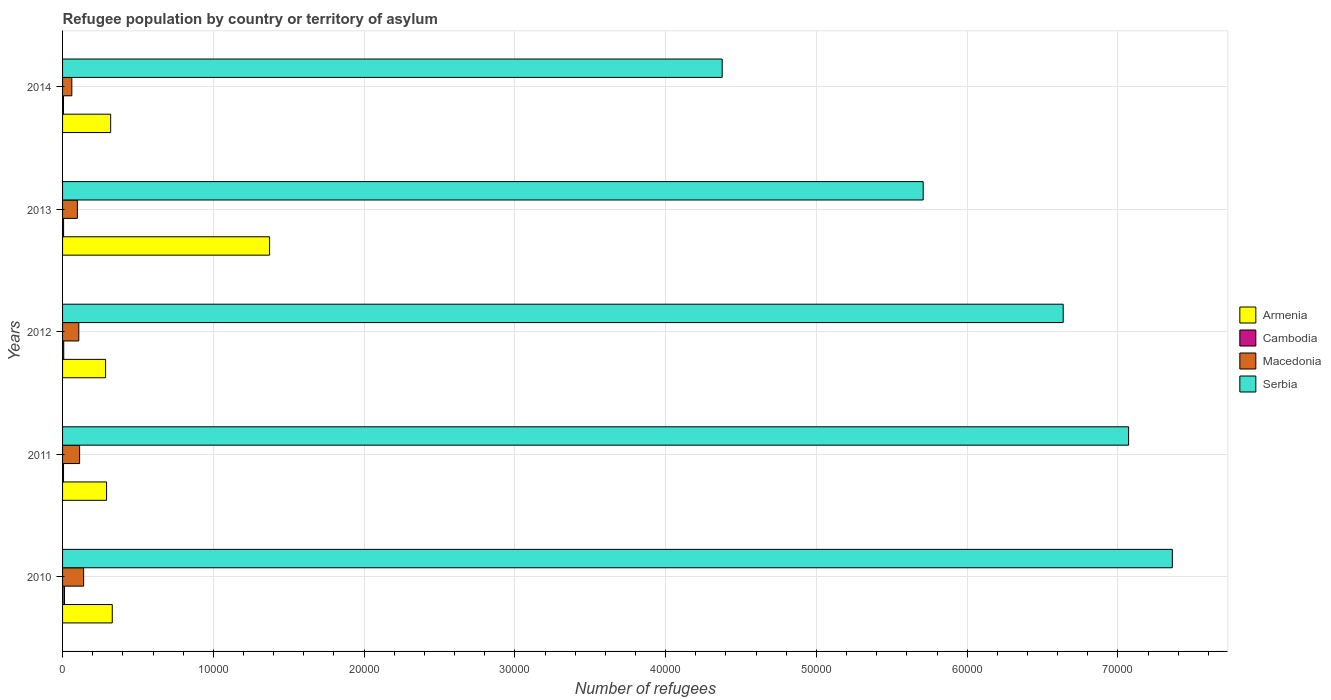How many bars are there on the 1st tick from the top?
Make the answer very short. 4. How many bars are there on the 5th tick from the bottom?
Provide a short and direct response. 4. In how many cases, is the number of bars for a given year not equal to the number of legend labels?
Your answer should be very brief. 0. Across all years, what is the maximum number of refugees in Armenia?
Offer a terse response. 1.37e+04. Across all years, what is the minimum number of refugees in Macedonia?
Offer a terse response. 614. In which year was the number of refugees in Cambodia maximum?
Provide a short and direct response. 2010. What is the total number of refugees in Macedonia in the graph?
Your answer should be very brief. 5201. What is the difference between the number of refugees in Armenia in 2012 and that in 2014?
Provide a short and direct response. -336. What is the difference between the number of refugees in Cambodia in 2010 and the number of refugees in Serbia in 2014?
Ensure brevity in your answer.  -4.36e+04. What is the average number of refugees in Cambodia per year?
Your answer should be compact. 80.2. In the year 2011, what is the difference between the number of refugees in Serbia and number of refugees in Armenia?
Keep it short and to the point. 6.78e+04. In how many years, is the number of refugees in Macedonia greater than 30000 ?
Make the answer very short. 0. What is the ratio of the number of refugees in Cambodia in 2011 to that in 2013?
Give a very brief answer. 0.94. Is the number of refugees in Armenia in 2010 less than that in 2011?
Provide a short and direct response. No. Is the difference between the number of refugees in Serbia in 2011 and 2012 greater than the difference between the number of refugees in Armenia in 2011 and 2012?
Your answer should be compact. Yes. What is the difference between the highest and the second highest number of refugees in Serbia?
Provide a succinct answer. 2901. In how many years, is the number of refugees in Serbia greater than the average number of refugees in Serbia taken over all years?
Your answer should be very brief. 3. What does the 1st bar from the top in 2010 represents?
Provide a succinct answer. Serbia. What does the 2nd bar from the bottom in 2010 represents?
Offer a terse response. Cambodia. Is it the case that in every year, the sum of the number of refugees in Macedonia and number of refugees in Armenia is greater than the number of refugees in Cambodia?
Offer a very short reply. Yes. Are all the bars in the graph horizontal?
Make the answer very short. Yes. How many years are there in the graph?
Offer a terse response. 5. What is the difference between two consecutive major ticks on the X-axis?
Offer a terse response. 10000. Are the values on the major ticks of X-axis written in scientific E-notation?
Your answer should be very brief. No. Where does the legend appear in the graph?
Your answer should be compact. Center right. What is the title of the graph?
Ensure brevity in your answer.  Refugee population by country or territory of asylum. Does "Faeroe Islands" appear as one of the legend labels in the graph?
Provide a short and direct response. No. What is the label or title of the X-axis?
Ensure brevity in your answer.  Number of refugees. What is the label or title of the Y-axis?
Make the answer very short. Years. What is the Number of refugees in Armenia in 2010?
Keep it short and to the point. 3296. What is the Number of refugees of Cambodia in 2010?
Your answer should be compact. 129. What is the Number of refugees in Macedonia in 2010?
Give a very brief answer. 1398. What is the Number of refugees of Serbia in 2010?
Make the answer very short. 7.36e+04. What is the Number of refugees of Armenia in 2011?
Keep it short and to the point. 2918. What is the Number of refugees in Cambodia in 2011?
Your answer should be compact. 64. What is the Number of refugees of Macedonia in 2011?
Offer a terse response. 1130. What is the Number of refugees of Serbia in 2011?
Provide a short and direct response. 7.07e+04. What is the Number of refugees of Armenia in 2012?
Offer a terse response. 2854. What is the Number of refugees in Macedonia in 2012?
Provide a succinct answer. 1077. What is the Number of refugees in Serbia in 2012?
Keep it short and to the point. 6.64e+04. What is the Number of refugees of Armenia in 2013?
Make the answer very short. 1.37e+04. What is the Number of refugees in Cambodia in 2013?
Offer a very short reply. 68. What is the Number of refugees of Macedonia in 2013?
Your answer should be very brief. 982. What is the Number of refugees of Serbia in 2013?
Your answer should be compact. 5.71e+04. What is the Number of refugees in Armenia in 2014?
Your answer should be compact. 3190. What is the Number of refugees of Cambodia in 2014?
Make the answer very short. 63. What is the Number of refugees of Macedonia in 2014?
Ensure brevity in your answer.  614. What is the Number of refugees in Serbia in 2014?
Provide a short and direct response. 4.38e+04. Across all years, what is the maximum Number of refugees in Armenia?
Your answer should be compact. 1.37e+04. Across all years, what is the maximum Number of refugees of Cambodia?
Make the answer very short. 129. Across all years, what is the maximum Number of refugees in Macedonia?
Provide a succinct answer. 1398. Across all years, what is the maximum Number of refugees in Serbia?
Offer a very short reply. 7.36e+04. Across all years, what is the minimum Number of refugees of Armenia?
Provide a short and direct response. 2854. Across all years, what is the minimum Number of refugees of Macedonia?
Your response must be concise. 614. Across all years, what is the minimum Number of refugees of Serbia?
Your response must be concise. 4.38e+04. What is the total Number of refugees of Armenia in the graph?
Provide a succinct answer. 2.60e+04. What is the total Number of refugees of Cambodia in the graph?
Your response must be concise. 401. What is the total Number of refugees in Macedonia in the graph?
Keep it short and to the point. 5201. What is the total Number of refugees of Serbia in the graph?
Offer a terse response. 3.12e+05. What is the difference between the Number of refugees in Armenia in 2010 and that in 2011?
Make the answer very short. 378. What is the difference between the Number of refugees in Cambodia in 2010 and that in 2011?
Offer a terse response. 65. What is the difference between the Number of refugees of Macedonia in 2010 and that in 2011?
Offer a terse response. 268. What is the difference between the Number of refugees in Serbia in 2010 and that in 2011?
Offer a terse response. 2901. What is the difference between the Number of refugees of Armenia in 2010 and that in 2012?
Offer a very short reply. 442. What is the difference between the Number of refugees of Macedonia in 2010 and that in 2012?
Your answer should be very brief. 321. What is the difference between the Number of refugees of Serbia in 2010 and that in 2012?
Make the answer very short. 7238. What is the difference between the Number of refugees in Armenia in 2010 and that in 2013?
Keep it short and to the point. -1.04e+04. What is the difference between the Number of refugees of Cambodia in 2010 and that in 2013?
Provide a short and direct response. 61. What is the difference between the Number of refugees in Macedonia in 2010 and that in 2013?
Ensure brevity in your answer.  416. What is the difference between the Number of refugees in Serbia in 2010 and that in 2013?
Offer a terse response. 1.65e+04. What is the difference between the Number of refugees of Armenia in 2010 and that in 2014?
Your response must be concise. 106. What is the difference between the Number of refugees of Cambodia in 2010 and that in 2014?
Give a very brief answer. 66. What is the difference between the Number of refugees in Macedonia in 2010 and that in 2014?
Your answer should be very brief. 784. What is the difference between the Number of refugees in Serbia in 2010 and that in 2014?
Keep it short and to the point. 2.99e+04. What is the difference between the Number of refugees of Armenia in 2011 and that in 2012?
Ensure brevity in your answer.  64. What is the difference between the Number of refugees in Cambodia in 2011 and that in 2012?
Make the answer very short. -13. What is the difference between the Number of refugees in Macedonia in 2011 and that in 2012?
Make the answer very short. 53. What is the difference between the Number of refugees in Serbia in 2011 and that in 2012?
Your answer should be very brief. 4337. What is the difference between the Number of refugees of Armenia in 2011 and that in 2013?
Offer a terse response. -1.08e+04. What is the difference between the Number of refugees of Macedonia in 2011 and that in 2013?
Keep it short and to the point. 148. What is the difference between the Number of refugees in Serbia in 2011 and that in 2013?
Your answer should be compact. 1.36e+04. What is the difference between the Number of refugees of Armenia in 2011 and that in 2014?
Your answer should be very brief. -272. What is the difference between the Number of refugees of Macedonia in 2011 and that in 2014?
Make the answer very short. 516. What is the difference between the Number of refugees in Serbia in 2011 and that in 2014?
Provide a short and direct response. 2.70e+04. What is the difference between the Number of refugees in Armenia in 2012 and that in 2013?
Offer a terse response. -1.09e+04. What is the difference between the Number of refugees in Macedonia in 2012 and that in 2013?
Your answer should be very brief. 95. What is the difference between the Number of refugees of Serbia in 2012 and that in 2013?
Ensure brevity in your answer.  9287. What is the difference between the Number of refugees in Armenia in 2012 and that in 2014?
Keep it short and to the point. -336. What is the difference between the Number of refugees in Macedonia in 2012 and that in 2014?
Offer a terse response. 463. What is the difference between the Number of refugees of Serbia in 2012 and that in 2014?
Make the answer very short. 2.26e+04. What is the difference between the Number of refugees of Armenia in 2013 and that in 2014?
Provide a succinct answer. 1.05e+04. What is the difference between the Number of refugees of Macedonia in 2013 and that in 2014?
Your response must be concise. 368. What is the difference between the Number of refugees of Serbia in 2013 and that in 2014?
Your answer should be very brief. 1.33e+04. What is the difference between the Number of refugees in Armenia in 2010 and the Number of refugees in Cambodia in 2011?
Make the answer very short. 3232. What is the difference between the Number of refugees in Armenia in 2010 and the Number of refugees in Macedonia in 2011?
Ensure brevity in your answer.  2166. What is the difference between the Number of refugees of Armenia in 2010 and the Number of refugees of Serbia in 2011?
Your answer should be compact. -6.74e+04. What is the difference between the Number of refugees of Cambodia in 2010 and the Number of refugees of Macedonia in 2011?
Ensure brevity in your answer.  -1001. What is the difference between the Number of refugees in Cambodia in 2010 and the Number of refugees in Serbia in 2011?
Keep it short and to the point. -7.06e+04. What is the difference between the Number of refugees of Macedonia in 2010 and the Number of refugees of Serbia in 2011?
Ensure brevity in your answer.  -6.93e+04. What is the difference between the Number of refugees in Armenia in 2010 and the Number of refugees in Cambodia in 2012?
Ensure brevity in your answer.  3219. What is the difference between the Number of refugees in Armenia in 2010 and the Number of refugees in Macedonia in 2012?
Keep it short and to the point. 2219. What is the difference between the Number of refugees in Armenia in 2010 and the Number of refugees in Serbia in 2012?
Offer a terse response. -6.31e+04. What is the difference between the Number of refugees in Cambodia in 2010 and the Number of refugees in Macedonia in 2012?
Your response must be concise. -948. What is the difference between the Number of refugees of Cambodia in 2010 and the Number of refugees of Serbia in 2012?
Keep it short and to the point. -6.62e+04. What is the difference between the Number of refugees in Macedonia in 2010 and the Number of refugees in Serbia in 2012?
Provide a short and direct response. -6.50e+04. What is the difference between the Number of refugees in Armenia in 2010 and the Number of refugees in Cambodia in 2013?
Provide a succinct answer. 3228. What is the difference between the Number of refugees of Armenia in 2010 and the Number of refugees of Macedonia in 2013?
Ensure brevity in your answer.  2314. What is the difference between the Number of refugees of Armenia in 2010 and the Number of refugees of Serbia in 2013?
Offer a very short reply. -5.38e+04. What is the difference between the Number of refugees of Cambodia in 2010 and the Number of refugees of Macedonia in 2013?
Your answer should be very brief. -853. What is the difference between the Number of refugees of Cambodia in 2010 and the Number of refugees of Serbia in 2013?
Provide a short and direct response. -5.70e+04. What is the difference between the Number of refugees of Macedonia in 2010 and the Number of refugees of Serbia in 2013?
Provide a succinct answer. -5.57e+04. What is the difference between the Number of refugees of Armenia in 2010 and the Number of refugees of Cambodia in 2014?
Provide a succinct answer. 3233. What is the difference between the Number of refugees of Armenia in 2010 and the Number of refugees of Macedonia in 2014?
Your answer should be very brief. 2682. What is the difference between the Number of refugees in Armenia in 2010 and the Number of refugees in Serbia in 2014?
Provide a succinct answer. -4.05e+04. What is the difference between the Number of refugees of Cambodia in 2010 and the Number of refugees of Macedonia in 2014?
Your answer should be compact. -485. What is the difference between the Number of refugees of Cambodia in 2010 and the Number of refugees of Serbia in 2014?
Offer a very short reply. -4.36e+04. What is the difference between the Number of refugees in Macedonia in 2010 and the Number of refugees in Serbia in 2014?
Provide a succinct answer. -4.24e+04. What is the difference between the Number of refugees in Armenia in 2011 and the Number of refugees in Cambodia in 2012?
Your answer should be very brief. 2841. What is the difference between the Number of refugees of Armenia in 2011 and the Number of refugees of Macedonia in 2012?
Make the answer very short. 1841. What is the difference between the Number of refugees of Armenia in 2011 and the Number of refugees of Serbia in 2012?
Offer a terse response. -6.35e+04. What is the difference between the Number of refugees of Cambodia in 2011 and the Number of refugees of Macedonia in 2012?
Give a very brief answer. -1013. What is the difference between the Number of refugees of Cambodia in 2011 and the Number of refugees of Serbia in 2012?
Provide a succinct answer. -6.63e+04. What is the difference between the Number of refugees of Macedonia in 2011 and the Number of refugees of Serbia in 2012?
Offer a very short reply. -6.52e+04. What is the difference between the Number of refugees of Armenia in 2011 and the Number of refugees of Cambodia in 2013?
Offer a terse response. 2850. What is the difference between the Number of refugees of Armenia in 2011 and the Number of refugees of Macedonia in 2013?
Keep it short and to the point. 1936. What is the difference between the Number of refugees of Armenia in 2011 and the Number of refugees of Serbia in 2013?
Your response must be concise. -5.42e+04. What is the difference between the Number of refugees of Cambodia in 2011 and the Number of refugees of Macedonia in 2013?
Your response must be concise. -918. What is the difference between the Number of refugees in Cambodia in 2011 and the Number of refugees in Serbia in 2013?
Make the answer very short. -5.70e+04. What is the difference between the Number of refugees of Macedonia in 2011 and the Number of refugees of Serbia in 2013?
Offer a very short reply. -5.60e+04. What is the difference between the Number of refugees in Armenia in 2011 and the Number of refugees in Cambodia in 2014?
Your answer should be very brief. 2855. What is the difference between the Number of refugees in Armenia in 2011 and the Number of refugees in Macedonia in 2014?
Offer a terse response. 2304. What is the difference between the Number of refugees of Armenia in 2011 and the Number of refugees of Serbia in 2014?
Offer a very short reply. -4.08e+04. What is the difference between the Number of refugees of Cambodia in 2011 and the Number of refugees of Macedonia in 2014?
Provide a succinct answer. -550. What is the difference between the Number of refugees of Cambodia in 2011 and the Number of refugees of Serbia in 2014?
Make the answer very short. -4.37e+04. What is the difference between the Number of refugees in Macedonia in 2011 and the Number of refugees in Serbia in 2014?
Give a very brief answer. -4.26e+04. What is the difference between the Number of refugees in Armenia in 2012 and the Number of refugees in Cambodia in 2013?
Your answer should be compact. 2786. What is the difference between the Number of refugees of Armenia in 2012 and the Number of refugees of Macedonia in 2013?
Ensure brevity in your answer.  1872. What is the difference between the Number of refugees of Armenia in 2012 and the Number of refugees of Serbia in 2013?
Provide a succinct answer. -5.42e+04. What is the difference between the Number of refugees in Cambodia in 2012 and the Number of refugees in Macedonia in 2013?
Your answer should be compact. -905. What is the difference between the Number of refugees in Cambodia in 2012 and the Number of refugees in Serbia in 2013?
Provide a succinct answer. -5.70e+04. What is the difference between the Number of refugees in Macedonia in 2012 and the Number of refugees in Serbia in 2013?
Your answer should be compact. -5.60e+04. What is the difference between the Number of refugees of Armenia in 2012 and the Number of refugees of Cambodia in 2014?
Provide a succinct answer. 2791. What is the difference between the Number of refugees of Armenia in 2012 and the Number of refugees of Macedonia in 2014?
Your response must be concise. 2240. What is the difference between the Number of refugees in Armenia in 2012 and the Number of refugees in Serbia in 2014?
Your answer should be compact. -4.09e+04. What is the difference between the Number of refugees in Cambodia in 2012 and the Number of refugees in Macedonia in 2014?
Your answer should be very brief. -537. What is the difference between the Number of refugees of Cambodia in 2012 and the Number of refugees of Serbia in 2014?
Ensure brevity in your answer.  -4.37e+04. What is the difference between the Number of refugees of Macedonia in 2012 and the Number of refugees of Serbia in 2014?
Offer a very short reply. -4.27e+04. What is the difference between the Number of refugees of Armenia in 2013 and the Number of refugees of Cambodia in 2014?
Your answer should be very brief. 1.37e+04. What is the difference between the Number of refugees in Armenia in 2013 and the Number of refugees in Macedonia in 2014?
Keep it short and to the point. 1.31e+04. What is the difference between the Number of refugees of Armenia in 2013 and the Number of refugees of Serbia in 2014?
Give a very brief answer. -3.00e+04. What is the difference between the Number of refugees in Cambodia in 2013 and the Number of refugees in Macedonia in 2014?
Provide a short and direct response. -546. What is the difference between the Number of refugees in Cambodia in 2013 and the Number of refugees in Serbia in 2014?
Give a very brief answer. -4.37e+04. What is the difference between the Number of refugees in Macedonia in 2013 and the Number of refugees in Serbia in 2014?
Your answer should be compact. -4.28e+04. What is the average Number of refugees in Armenia per year?
Provide a short and direct response. 5198. What is the average Number of refugees in Cambodia per year?
Your response must be concise. 80.2. What is the average Number of refugees of Macedonia per year?
Your answer should be compact. 1040.2. What is the average Number of refugees in Serbia per year?
Keep it short and to the point. 6.23e+04. In the year 2010, what is the difference between the Number of refugees in Armenia and Number of refugees in Cambodia?
Ensure brevity in your answer.  3167. In the year 2010, what is the difference between the Number of refugees of Armenia and Number of refugees of Macedonia?
Your answer should be very brief. 1898. In the year 2010, what is the difference between the Number of refugees in Armenia and Number of refugees in Serbia?
Offer a very short reply. -7.03e+04. In the year 2010, what is the difference between the Number of refugees of Cambodia and Number of refugees of Macedonia?
Offer a terse response. -1269. In the year 2010, what is the difference between the Number of refugees in Cambodia and Number of refugees in Serbia?
Offer a terse response. -7.35e+04. In the year 2010, what is the difference between the Number of refugees of Macedonia and Number of refugees of Serbia?
Offer a very short reply. -7.22e+04. In the year 2011, what is the difference between the Number of refugees of Armenia and Number of refugees of Cambodia?
Your answer should be very brief. 2854. In the year 2011, what is the difference between the Number of refugees in Armenia and Number of refugees in Macedonia?
Give a very brief answer. 1788. In the year 2011, what is the difference between the Number of refugees in Armenia and Number of refugees in Serbia?
Your answer should be very brief. -6.78e+04. In the year 2011, what is the difference between the Number of refugees of Cambodia and Number of refugees of Macedonia?
Ensure brevity in your answer.  -1066. In the year 2011, what is the difference between the Number of refugees in Cambodia and Number of refugees in Serbia?
Offer a terse response. -7.06e+04. In the year 2011, what is the difference between the Number of refugees of Macedonia and Number of refugees of Serbia?
Your answer should be very brief. -6.96e+04. In the year 2012, what is the difference between the Number of refugees of Armenia and Number of refugees of Cambodia?
Keep it short and to the point. 2777. In the year 2012, what is the difference between the Number of refugees of Armenia and Number of refugees of Macedonia?
Your answer should be compact. 1777. In the year 2012, what is the difference between the Number of refugees of Armenia and Number of refugees of Serbia?
Give a very brief answer. -6.35e+04. In the year 2012, what is the difference between the Number of refugees of Cambodia and Number of refugees of Macedonia?
Keep it short and to the point. -1000. In the year 2012, what is the difference between the Number of refugees of Cambodia and Number of refugees of Serbia?
Your response must be concise. -6.63e+04. In the year 2012, what is the difference between the Number of refugees in Macedonia and Number of refugees in Serbia?
Provide a succinct answer. -6.53e+04. In the year 2013, what is the difference between the Number of refugees of Armenia and Number of refugees of Cambodia?
Keep it short and to the point. 1.37e+04. In the year 2013, what is the difference between the Number of refugees in Armenia and Number of refugees in Macedonia?
Offer a very short reply. 1.28e+04. In the year 2013, what is the difference between the Number of refugees of Armenia and Number of refugees of Serbia?
Offer a terse response. -4.34e+04. In the year 2013, what is the difference between the Number of refugees in Cambodia and Number of refugees in Macedonia?
Your answer should be compact. -914. In the year 2013, what is the difference between the Number of refugees in Cambodia and Number of refugees in Serbia?
Ensure brevity in your answer.  -5.70e+04. In the year 2013, what is the difference between the Number of refugees of Macedonia and Number of refugees of Serbia?
Ensure brevity in your answer.  -5.61e+04. In the year 2014, what is the difference between the Number of refugees of Armenia and Number of refugees of Cambodia?
Provide a succinct answer. 3127. In the year 2014, what is the difference between the Number of refugees in Armenia and Number of refugees in Macedonia?
Provide a succinct answer. 2576. In the year 2014, what is the difference between the Number of refugees of Armenia and Number of refugees of Serbia?
Provide a short and direct response. -4.06e+04. In the year 2014, what is the difference between the Number of refugees of Cambodia and Number of refugees of Macedonia?
Make the answer very short. -551. In the year 2014, what is the difference between the Number of refugees in Cambodia and Number of refugees in Serbia?
Your answer should be very brief. -4.37e+04. In the year 2014, what is the difference between the Number of refugees in Macedonia and Number of refugees in Serbia?
Your response must be concise. -4.31e+04. What is the ratio of the Number of refugees in Armenia in 2010 to that in 2011?
Keep it short and to the point. 1.13. What is the ratio of the Number of refugees in Cambodia in 2010 to that in 2011?
Your response must be concise. 2.02. What is the ratio of the Number of refugees of Macedonia in 2010 to that in 2011?
Keep it short and to the point. 1.24. What is the ratio of the Number of refugees of Serbia in 2010 to that in 2011?
Provide a short and direct response. 1.04. What is the ratio of the Number of refugees in Armenia in 2010 to that in 2012?
Ensure brevity in your answer.  1.15. What is the ratio of the Number of refugees of Cambodia in 2010 to that in 2012?
Provide a short and direct response. 1.68. What is the ratio of the Number of refugees of Macedonia in 2010 to that in 2012?
Your answer should be compact. 1.3. What is the ratio of the Number of refugees in Serbia in 2010 to that in 2012?
Offer a terse response. 1.11. What is the ratio of the Number of refugees of Armenia in 2010 to that in 2013?
Your response must be concise. 0.24. What is the ratio of the Number of refugees in Cambodia in 2010 to that in 2013?
Keep it short and to the point. 1.9. What is the ratio of the Number of refugees of Macedonia in 2010 to that in 2013?
Provide a short and direct response. 1.42. What is the ratio of the Number of refugees in Serbia in 2010 to that in 2013?
Offer a terse response. 1.29. What is the ratio of the Number of refugees of Armenia in 2010 to that in 2014?
Your response must be concise. 1.03. What is the ratio of the Number of refugees of Cambodia in 2010 to that in 2014?
Offer a very short reply. 2.05. What is the ratio of the Number of refugees of Macedonia in 2010 to that in 2014?
Make the answer very short. 2.28. What is the ratio of the Number of refugees in Serbia in 2010 to that in 2014?
Ensure brevity in your answer.  1.68. What is the ratio of the Number of refugees in Armenia in 2011 to that in 2012?
Offer a terse response. 1.02. What is the ratio of the Number of refugees of Cambodia in 2011 to that in 2012?
Offer a very short reply. 0.83. What is the ratio of the Number of refugees in Macedonia in 2011 to that in 2012?
Your response must be concise. 1.05. What is the ratio of the Number of refugees in Serbia in 2011 to that in 2012?
Your answer should be compact. 1.07. What is the ratio of the Number of refugees in Armenia in 2011 to that in 2013?
Give a very brief answer. 0.21. What is the ratio of the Number of refugees in Macedonia in 2011 to that in 2013?
Your response must be concise. 1.15. What is the ratio of the Number of refugees of Serbia in 2011 to that in 2013?
Ensure brevity in your answer.  1.24. What is the ratio of the Number of refugees of Armenia in 2011 to that in 2014?
Keep it short and to the point. 0.91. What is the ratio of the Number of refugees in Cambodia in 2011 to that in 2014?
Offer a terse response. 1.02. What is the ratio of the Number of refugees of Macedonia in 2011 to that in 2014?
Offer a very short reply. 1.84. What is the ratio of the Number of refugees in Serbia in 2011 to that in 2014?
Offer a very short reply. 1.62. What is the ratio of the Number of refugees of Armenia in 2012 to that in 2013?
Ensure brevity in your answer.  0.21. What is the ratio of the Number of refugees of Cambodia in 2012 to that in 2013?
Offer a very short reply. 1.13. What is the ratio of the Number of refugees in Macedonia in 2012 to that in 2013?
Offer a terse response. 1.1. What is the ratio of the Number of refugees in Serbia in 2012 to that in 2013?
Give a very brief answer. 1.16. What is the ratio of the Number of refugees in Armenia in 2012 to that in 2014?
Give a very brief answer. 0.89. What is the ratio of the Number of refugees of Cambodia in 2012 to that in 2014?
Your answer should be compact. 1.22. What is the ratio of the Number of refugees of Macedonia in 2012 to that in 2014?
Offer a very short reply. 1.75. What is the ratio of the Number of refugees in Serbia in 2012 to that in 2014?
Your answer should be compact. 1.52. What is the ratio of the Number of refugees in Armenia in 2013 to that in 2014?
Provide a short and direct response. 4.3. What is the ratio of the Number of refugees in Cambodia in 2013 to that in 2014?
Your answer should be very brief. 1.08. What is the ratio of the Number of refugees in Macedonia in 2013 to that in 2014?
Keep it short and to the point. 1.6. What is the ratio of the Number of refugees in Serbia in 2013 to that in 2014?
Keep it short and to the point. 1.3. What is the difference between the highest and the second highest Number of refugees of Armenia?
Offer a terse response. 1.04e+04. What is the difference between the highest and the second highest Number of refugees in Cambodia?
Keep it short and to the point. 52. What is the difference between the highest and the second highest Number of refugees of Macedonia?
Give a very brief answer. 268. What is the difference between the highest and the second highest Number of refugees in Serbia?
Keep it short and to the point. 2901. What is the difference between the highest and the lowest Number of refugees in Armenia?
Ensure brevity in your answer.  1.09e+04. What is the difference between the highest and the lowest Number of refugees of Cambodia?
Provide a short and direct response. 66. What is the difference between the highest and the lowest Number of refugees in Macedonia?
Give a very brief answer. 784. What is the difference between the highest and the lowest Number of refugees of Serbia?
Make the answer very short. 2.99e+04. 